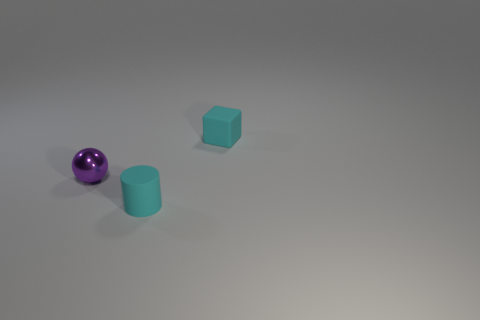There is a metal object that is the same size as the cyan cylinder; what is its shape?
Provide a short and direct response. Sphere. Is there any other thing that has the same color as the rubber cube?
Ensure brevity in your answer.  Yes. What size is the thing that is the same material as the tiny cyan cylinder?
Offer a very short reply. Small. There is a purple metal thing; does it have the same shape as the small cyan rubber thing that is to the left of the small rubber block?
Provide a succinct answer. No. The sphere is what size?
Your answer should be compact. Small. Are there fewer small balls behind the tiny metal thing than large purple metal spheres?
Keep it short and to the point. No. What number of brown spheres have the same size as the cylinder?
Provide a short and direct response. 0. The tiny rubber thing that is the same color as the tiny cylinder is what shape?
Keep it short and to the point. Cube. There is a tiny matte object behind the tiny metallic thing; is its color the same as the thing that is to the left of the small matte cylinder?
Your answer should be compact. No. There is a cyan matte block; how many cyan matte cylinders are left of it?
Your answer should be compact. 1. 